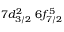Convert formula to latex. <formula><loc_0><loc_0><loc_500><loc_500>7 d _ { 3 / 2 } ^ { 2 } \, 6 f _ { 7 / 2 } ^ { 5 }</formula> 